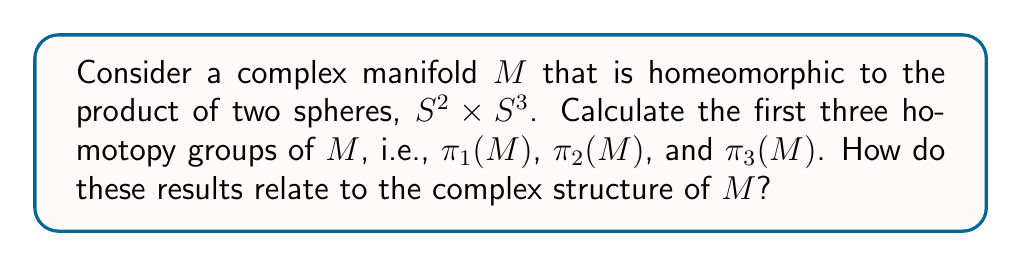Give your solution to this math problem. To analyze the homotopy groups of the complex manifold $M$, we'll follow these steps:

1) First, recall that $M$ is homeomorphic to $S^2 \times S^3$. This means that $M$ and $S^2 \times S^3$ have the same topological properties, including homotopy groups.

2) For product spaces, we can use the following theorem:
   $\pi_k(X \times Y) \cong \pi_k(X) \times \pi_k(Y)$ for all $k \geq 1$

3) Now, let's recall the homotopy groups of spheres:
   - $\pi_1(S^n) = 0$ for $n \geq 2$
   - $\pi_2(S^n) = 0$ for $n \geq 3$
   - $\pi_2(S^2) = \mathbb{Z}$
   - $\pi_3(S^3) = \mathbb{Z}$

4) Calculating $\pi_1(M)$:
   $\pi_1(M) \cong \pi_1(S^2 \times S^3) \cong \pi_1(S^2) \times \pi_1(S^3) \cong 0 \times 0 = 0$

5) Calculating $\pi_2(M)$:
   $\pi_2(M) \cong \pi_2(S^2 \times S^3) \cong \pi_2(S^2) \times \pi_2(S^3) \cong \mathbb{Z} \times 0 \cong \mathbb{Z}$

6) Calculating $\pi_3(M)$:
   $\pi_3(M) \cong \pi_3(S^2 \times S^3) \cong \pi_3(S^2) \times \pi_3(S^3) \cong \mathbb{Z} \times \mathbb{Z} \cong \mathbb{Z}^2$

7) Regarding the complex structure of $M$:
   The fact that $\pi_1(M) = 0$ means that $M$ is simply connected, which is a necessary condition for many complex manifolds, including Kähler manifolds.
   The non-trivial $\pi_2(M)$ and $\pi_3(M)$ indicate that $M$ has interesting higher-dimensional topology, which could potentially be related to its complex structure through tools like Hodge theory or Chern classes.
Answer: $\pi_1(M) = 0$, $\pi_2(M) \cong \mathbb{Z}$, $\pi_3(M) \cong \mathbb{Z}^2$. These results show that $M$ is simply connected but has non-trivial higher homotopy groups, which may have implications for its complex structure through tools like Hodge theory or Chern classes. 